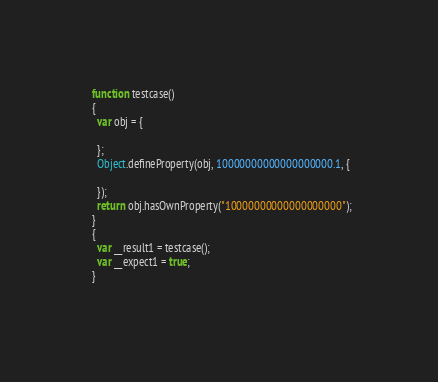Convert code to text. <code><loc_0><loc_0><loc_500><loc_500><_JavaScript_>  function testcase() 
  {
    var obj = {
      
    };
    Object.defineProperty(obj, 10000000000000000000.1, {
      
    });
    return obj.hasOwnProperty("10000000000000000000");
  }
  {
    var __result1 = testcase();
    var __expect1 = true;
  }
  
</code> 